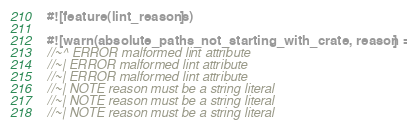Convert code to text. <code><loc_0><loc_0><loc_500><loc_500><_Rust_>#![feature(lint_reasons)]

#![warn(absolute_paths_not_starting_with_crate, reason = 0)]
//~^ ERROR malformed lint attribute
//~| ERROR malformed lint attribute
//~| ERROR malformed lint attribute
//~| NOTE reason must be a string literal
//~| NOTE reason must be a string literal
//~| NOTE reason must be a string literal</code> 